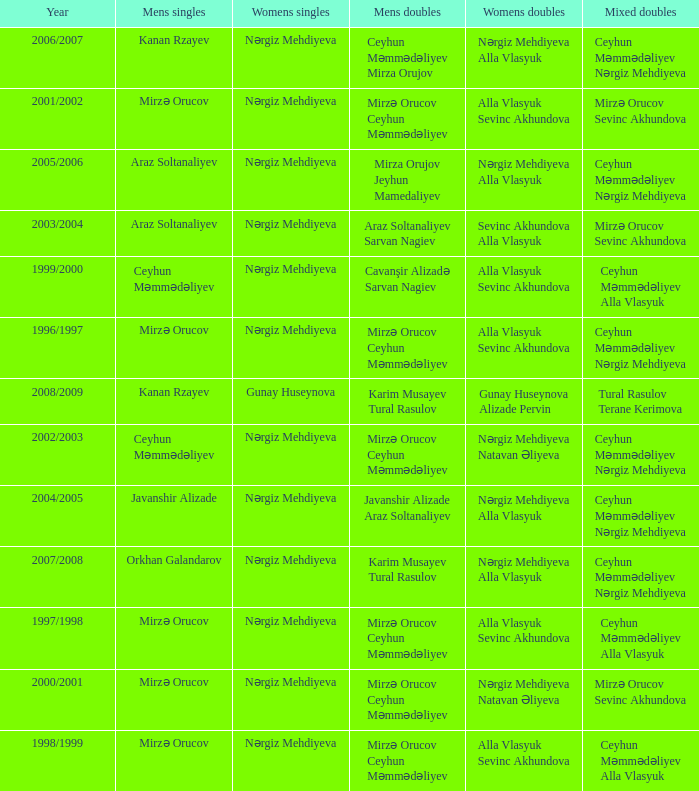Who were all womens doubles for the year 2000/2001? Nərgiz Mehdiyeva Natavan Əliyeva. 